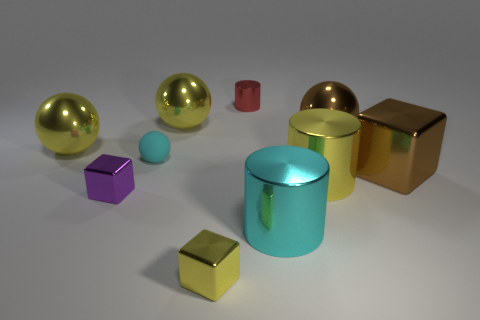Subtract all balls. How many objects are left? 6 Add 6 tiny purple shiny cubes. How many tiny purple shiny cubes are left? 7 Add 3 small cyan things. How many small cyan things exist? 4 Subtract 1 yellow balls. How many objects are left? 9 Subtract all big matte balls. Subtract all purple metallic objects. How many objects are left? 9 